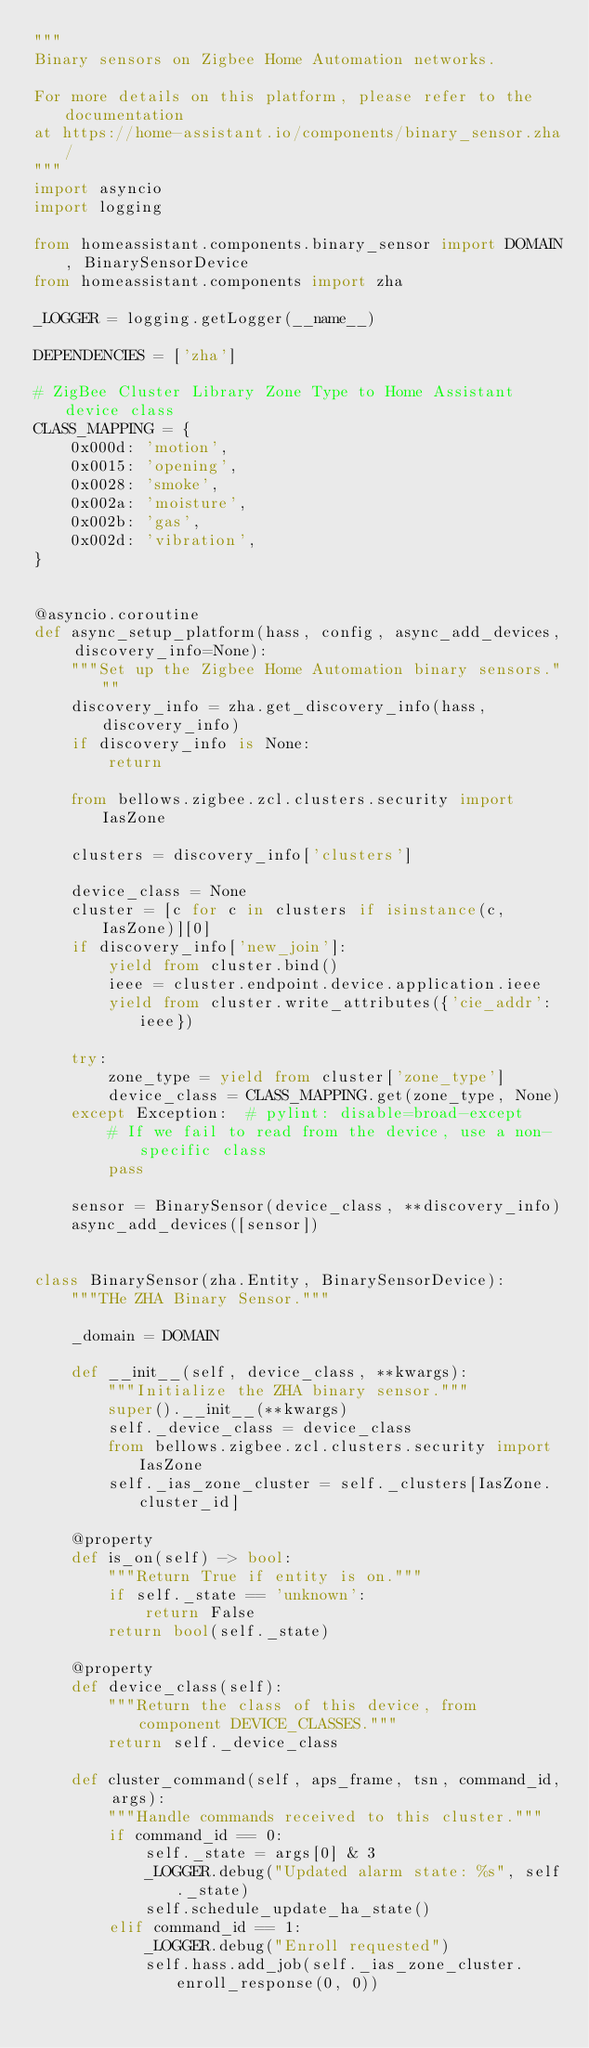<code> <loc_0><loc_0><loc_500><loc_500><_Python_>"""
Binary sensors on Zigbee Home Automation networks.

For more details on this platform, please refer to the documentation
at https://home-assistant.io/components/binary_sensor.zha/
"""
import asyncio
import logging

from homeassistant.components.binary_sensor import DOMAIN, BinarySensorDevice
from homeassistant.components import zha

_LOGGER = logging.getLogger(__name__)

DEPENDENCIES = ['zha']

# ZigBee Cluster Library Zone Type to Home Assistant device class
CLASS_MAPPING = {
    0x000d: 'motion',
    0x0015: 'opening',
    0x0028: 'smoke',
    0x002a: 'moisture',
    0x002b: 'gas',
    0x002d: 'vibration',
}


@asyncio.coroutine
def async_setup_platform(hass, config, async_add_devices, discovery_info=None):
    """Set up the Zigbee Home Automation binary sensors."""
    discovery_info = zha.get_discovery_info(hass, discovery_info)
    if discovery_info is None:
        return

    from bellows.zigbee.zcl.clusters.security import IasZone

    clusters = discovery_info['clusters']

    device_class = None
    cluster = [c for c in clusters if isinstance(c, IasZone)][0]
    if discovery_info['new_join']:
        yield from cluster.bind()
        ieee = cluster.endpoint.device.application.ieee
        yield from cluster.write_attributes({'cie_addr': ieee})

    try:
        zone_type = yield from cluster['zone_type']
        device_class = CLASS_MAPPING.get(zone_type, None)
    except Exception:  # pylint: disable=broad-except
        # If we fail to read from the device, use a non-specific class
        pass

    sensor = BinarySensor(device_class, **discovery_info)
    async_add_devices([sensor])


class BinarySensor(zha.Entity, BinarySensorDevice):
    """THe ZHA Binary Sensor."""

    _domain = DOMAIN

    def __init__(self, device_class, **kwargs):
        """Initialize the ZHA binary sensor."""
        super().__init__(**kwargs)
        self._device_class = device_class
        from bellows.zigbee.zcl.clusters.security import IasZone
        self._ias_zone_cluster = self._clusters[IasZone.cluster_id]

    @property
    def is_on(self) -> bool:
        """Return True if entity is on."""
        if self._state == 'unknown':
            return False
        return bool(self._state)

    @property
    def device_class(self):
        """Return the class of this device, from component DEVICE_CLASSES."""
        return self._device_class

    def cluster_command(self, aps_frame, tsn, command_id, args):
        """Handle commands received to this cluster."""
        if command_id == 0:
            self._state = args[0] & 3
            _LOGGER.debug("Updated alarm state: %s", self._state)
            self.schedule_update_ha_state()
        elif command_id == 1:
            _LOGGER.debug("Enroll requested")
            self.hass.add_job(self._ias_zone_cluster.enroll_response(0, 0))
</code> 